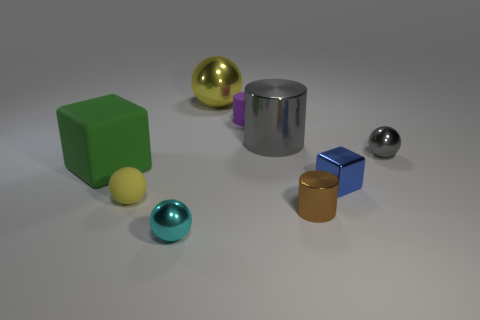The ball that is behind the cylinder that is to the left of the gray metallic cylinder in front of the small purple object is what color?
Offer a terse response. Yellow. How many other things are the same shape as the tiny brown metallic object?
Keep it short and to the point. 2. There is a tiny rubber object that is on the right side of the matte sphere; what is its shape?
Give a very brief answer. Cylinder. There is a small cylinder that is in front of the large green block; are there any tiny metallic objects in front of it?
Offer a terse response. Yes. There is a tiny object that is both in front of the blue cube and to the right of the gray metallic cylinder; what color is it?
Keep it short and to the point. Brown. There is a big thing that is in front of the shiny cylinder that is behind the big green cube; are there any large blocks behind it?
Ensure brevity in your answer.  No. What is the size of the other metallic object that is the same shape as the brown thing?
Provide a succinct answer. Large. Are any cyan shiny cylinders visible?
Provide a succinct answer. No. Is the color of the large cylinder the same as the tiny ball to the right of the small cyan metal sphere?
Provide a succinct answer. Yes. There is a shiny sphere on the right side of the cylinder in front of the tiny metal object behind the tiny blue object; what size is it?
Provide a succinct answer. Small. 